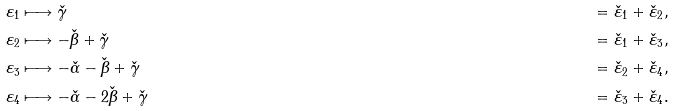Convert formula to latex. <formula><loc_0><loc_0><loc_500><loc_500>\varepsilon _ { 1 } & \longmapsto \check { \gamma } & = \check { \varepsilon } _ { 1 } + \check { \varepsilon } _ { 2 } , \\ \varepsilon _ { 2 } & \longmapsto - \check { \beta } + \check { \gamma } & = \check { \varepsilon } _ { 1 } + \check { \varepsilon } _ { 3 } , \\ \varepsilon _ { 3 } & \longmapsto - \check { \alpha } - \check { \beta } + \check { \gamma } & = \check { \varepsilon } _ { 2 } + \check { \varepsilon } _ { 4 } , \\ \varepsilon _ { 4 } & \longmapsto - \check { \alpha } - 2 \check { \beta } + \check { \gamma } & = \check { \varepsilon } _ { 3 } + \check { \varepsilon } _ { 4 } .</formula> 